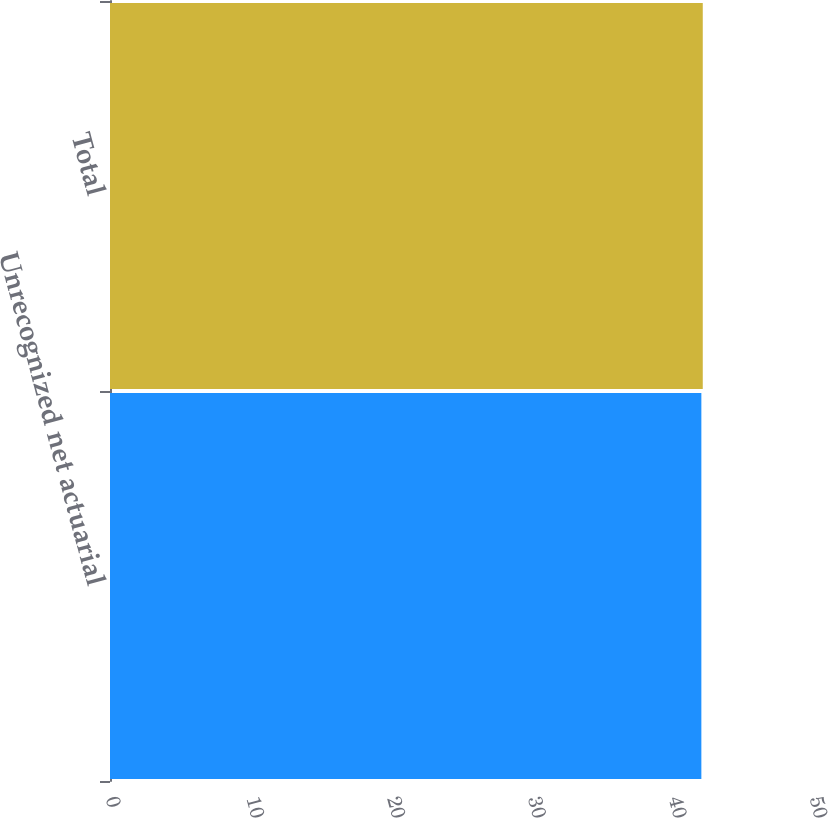Convert chart to OTSL. <chart><loc_0><loc_0><loc_500><loc_500><bar_chart><fcel>Unrecognized net actuarial<fcel>Total<nl><fcel>42<fcel>42.1<nl></chart> 